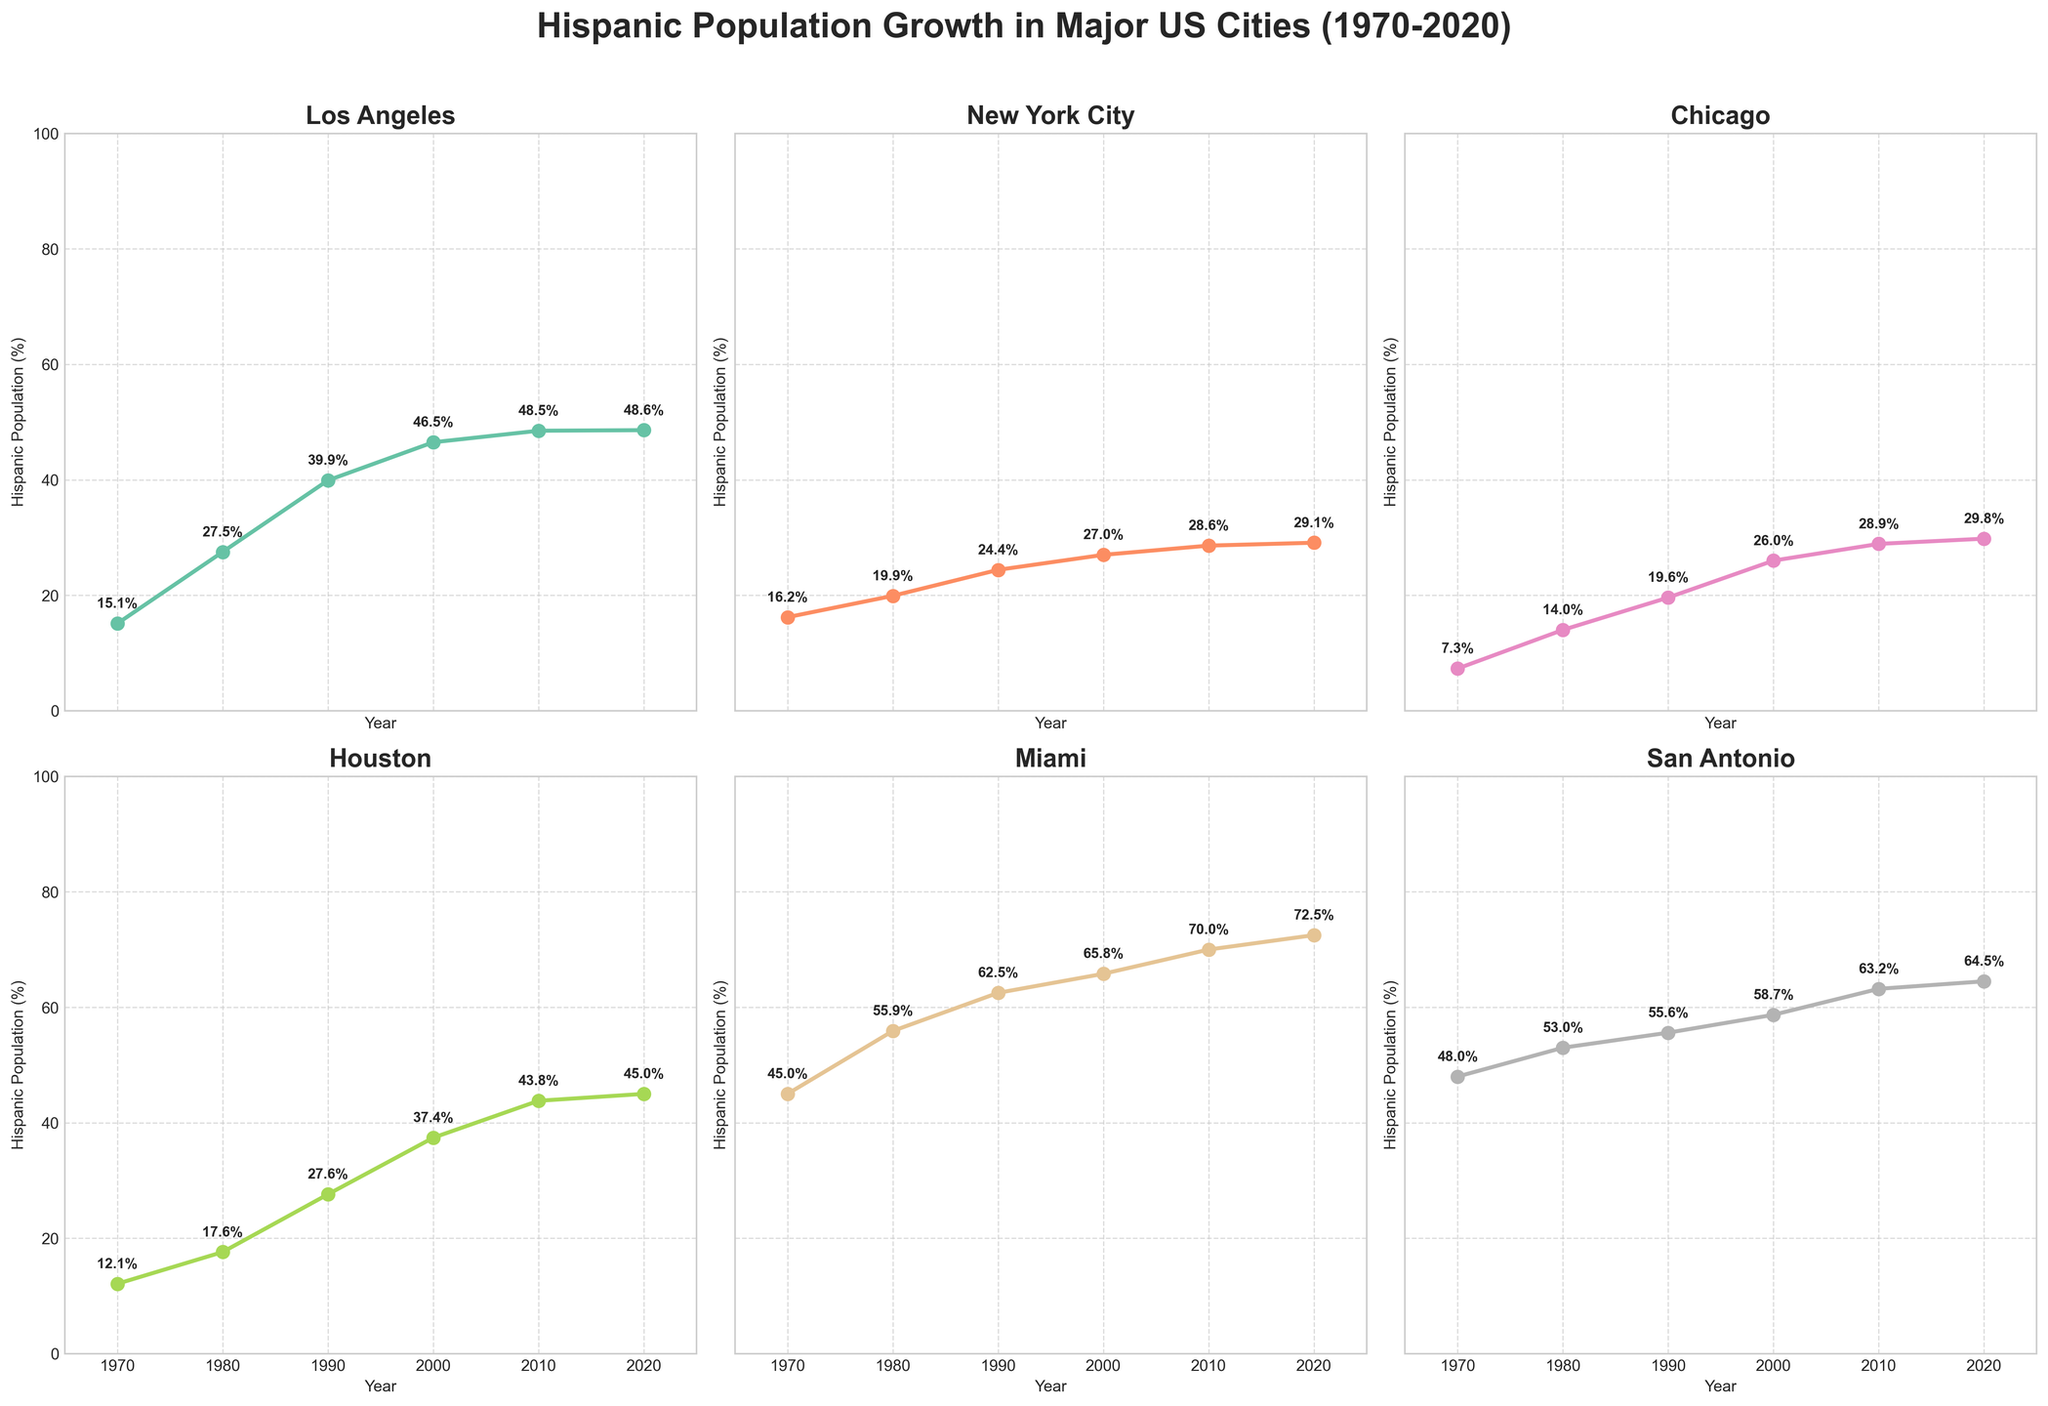what is the Hispanic population percentage of San Antonio in 2010? Look at the subplot for San Antonio and find the value corresponding to the year 2010.
Answer: 63.2% Which city had the highest Hispanic population percentage in 1990? Compare the values for all cities in the year 1990. Miami has the highest percentage.
Answer: Miami Which city experienced the greatest increase in Hispanic population percentage between 1970 and 2020? Calculate the difference between the 2020 and 1970 values for each city. Miami increased by 27.5%, the highest.
Answer: Miami In which decade did Chicago experience the highest growth in Hispanic population percentage? Look at the values for Chicago and compute the differences for each decade. The highest increase is from 1970 to 1980 (6.7%).
Answer: 1970-1980 How does the Hispanic population percentage in Los Angeles in 2020 compare to San Antonio in the same year? Compare the 2020 values for Los Angeles and San Antonio. Los Angeles has 48.6% and San Antonio has 64.5%; San Antonio is higher.
Answer: San Antonio is higher Which two cities had the closest Hispanic population percentages in 2000? Compare the values for all cities in the year 2000. San Antonio (58.7%) and Miami (65.8%) are closest, with a difference of 7.1%.
Answer: San Antonio and Miami What is the difference in the Hispanic population percentage between Houston and Chicago in 2020? Subtract the 2020 percentage for Chicago (29.8%) from Houston (45.0%).
Answer: 15.2% What is the average Hispanic population percentage for New York City across all years shown? Sum the percentages for New York City (16.2 + 19.9 + 24.4 + 27.0 + 28.6 + 29.1) and divide by 6.
Answer: 24.2% In which city do we see a percentage plateau from 2010 to 2020? Look at the subplots to identify a flat line from 2010 to 2020. Los Angeles shows this pattern (48.5% to 48.6%).
Answer: Los Angeles How many cities had a Hispanic population percentage greater than 50% in 1980? Check the values for each city in 1980. Only Miami (55.9%) and San Antonio (53.0%) exceed 50%.
Answer: 2 